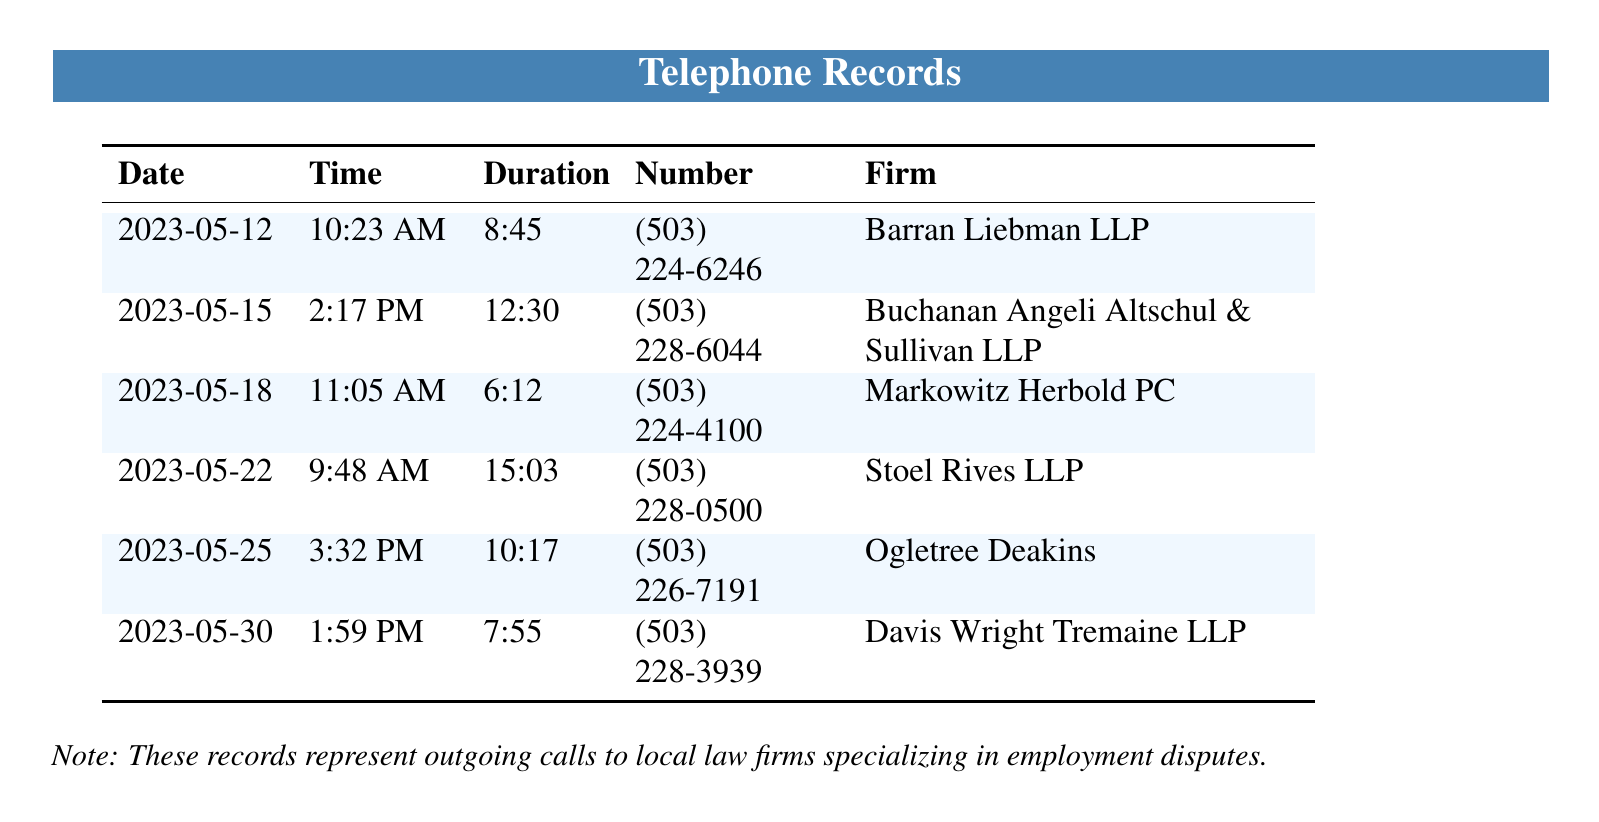what was the duration of the call on May 22, 2023? The duration of the call on May 22, 2023, is listed next to the date, which is 15:03.
Answer: 15:03 who did the call on May 18, 2023, go to? The firm associated with the call on May 18, 2023, is listed as Markowitz Herbold PC.
Answer: Markowitz Herbold PC how many calls were made in total? The total number of calls is the count of entries in the table, which adds up to six.
Answer: 6 which call had the longest duration? The longest duration can be found by comparing the durations listed; the longest is 15:03 on May 22, 2023.
Answer: 15:03 what is the phone number for Barran Liebman LLP? The phone number associated with Barran Liebman LLP is displayed in the number column, which is (503) 224-6246.
Answer: (503) 224-6246 when was the first outgoing call made? The first outgoing call can be determined by looking at the earliest date in the table, which is May 12, 2023.
Answer: May 12, 2023 which firm was contacted at 1:59 PM? The firm corresponding to the call at 1:59 PM is listed as Davis Wright Tremaine LLP.
Answer: Davis Wright Tremaine LLP what is the average duration of the calls listed? The average duration can be calculated by totaling the call durations and dividing by the number of calls, which requires further computation. The answer is 10:08.
Answer: 10:08 